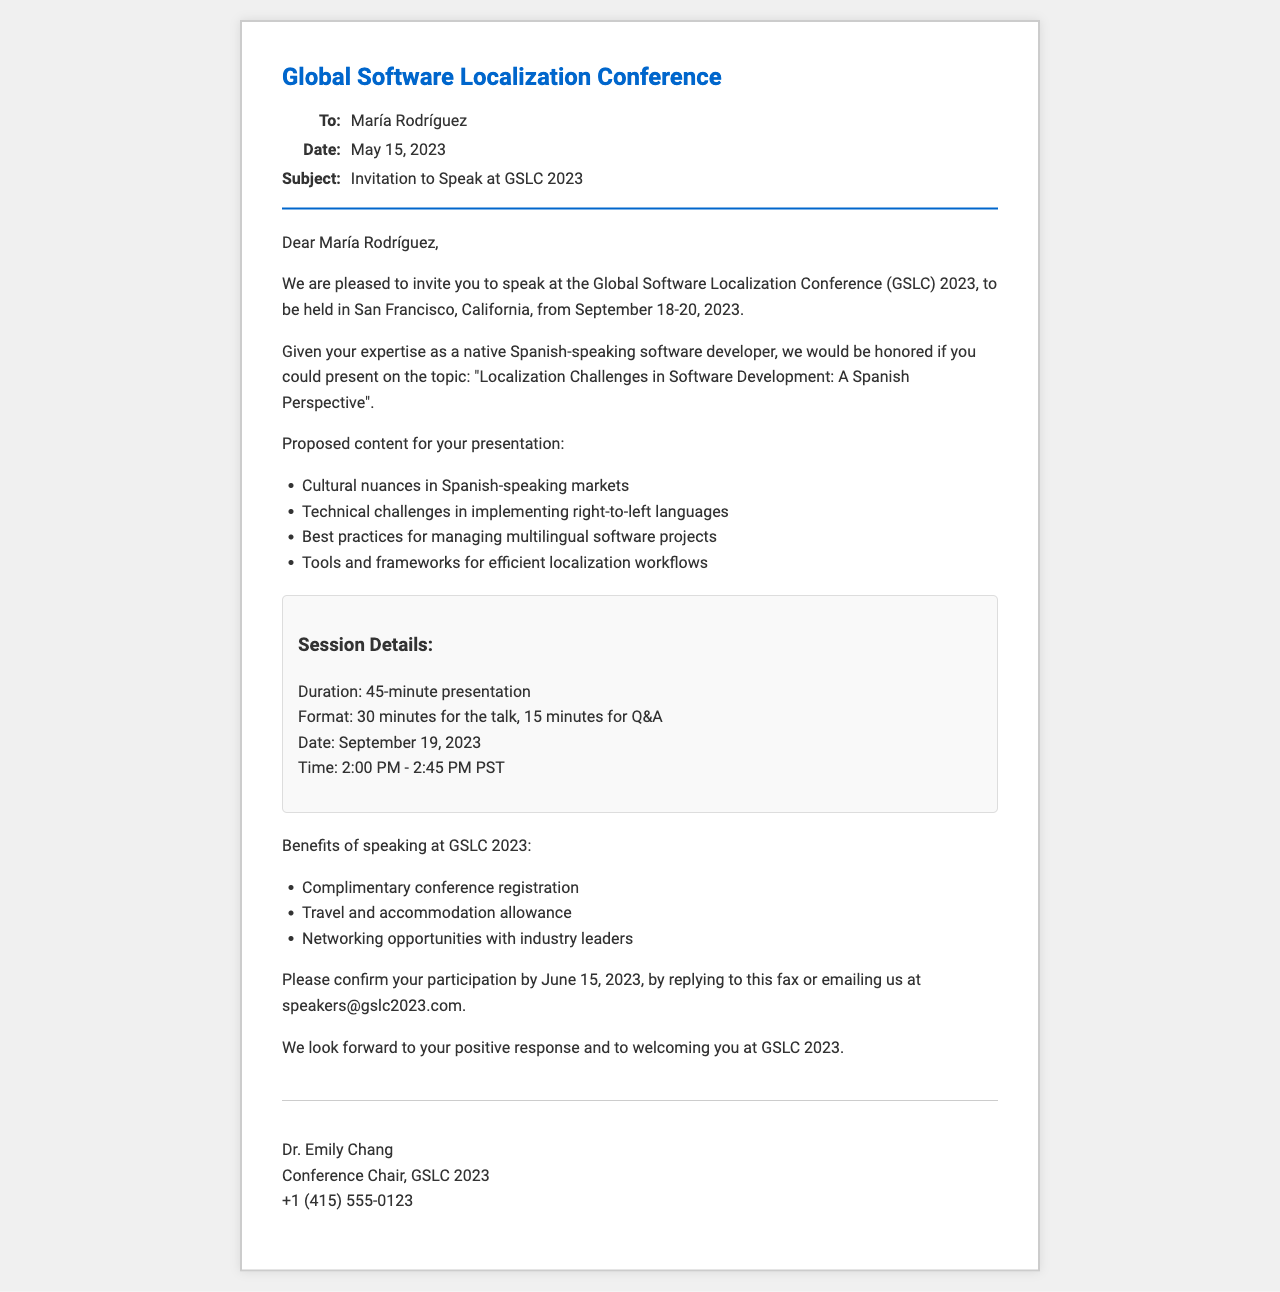What is the name of the conference? The conference mentioned in the document is the Global Software Localization Conference.
Answer: Global Software Localization Conference Who is the recipient of the invitation? The invitation is addressed to María Rodríguez.
Answer: María Rodríguez What is the date by which participation must be confirmed? The document specifies that participation should be confirmed by June 15, 2023.
Answer: June 15, 2023 What is the date of the presentation? According to the document, the presentation is scheduled for September 19, 2023.
Answer: September 19, 2023 How long is the presentation scheduled to last? The document states that the presentation will last 45 minutes.
Answer: 45 minutes What is one of the proposed topics for the presentation? One of the proposed topics is "Cultural nuances in Spanish-speaking markets."
Answer: Cultural nuances in Spanish-speaking markets What is included as a benefit of speaking at the conference? The document lists complimentary conference registration as one of the benefits.
Answer: Complimentary conference registration What is the time for the presentation? The time for the presentation is from 2:00 PM to 2:45 PM PST.
Answer: 2:00 PM - 2:45 PM PST Who signed the invitation? The invitation is signed by Dr. Emily Chang.
Answer: Dr. Emily Chang 